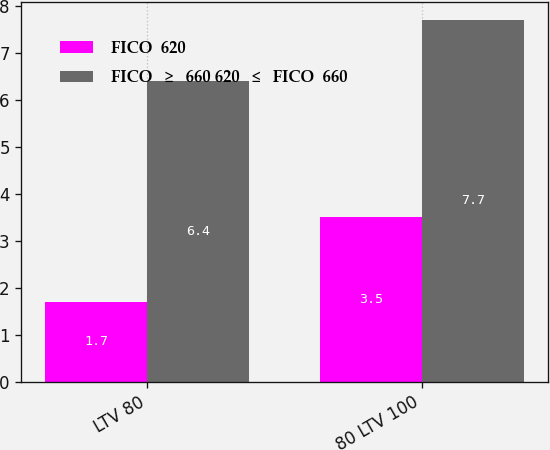Convert chart. <chart><loc_0><loc_0><loc_500><loc_500><stacked_bar_chart><ecel><fcel>LTV 80<fcel>80 LTV 100<nl><fcel>FICO  620<fcel>1.7<fcel>3.5<nl><fcel>FICO  ≥  660 620  ≤  FICO  660<fcel>6.4<fcel>7.7<nl></chart> 